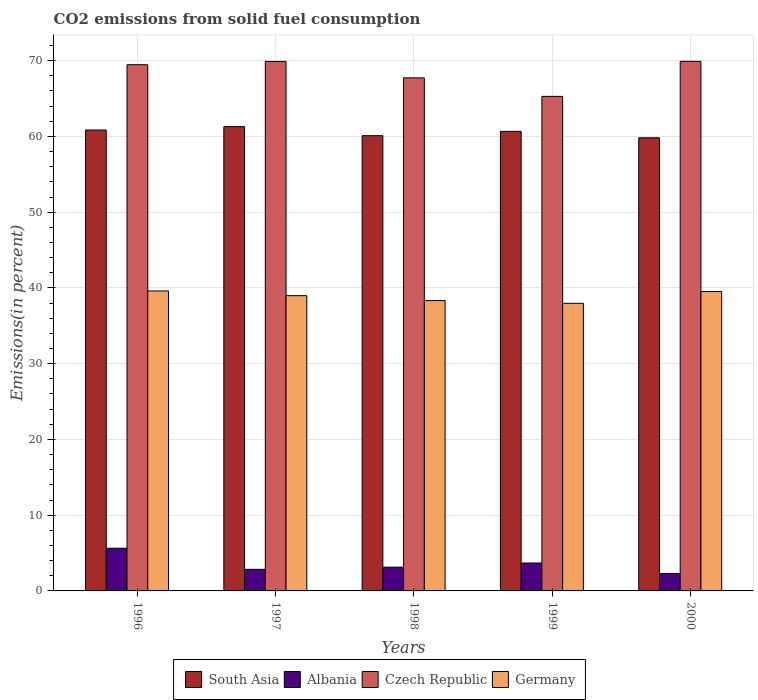How many groups of bars are there?
Offer a terse response. 5. Are the number of bars per tick equal to the number of legend labels?
Your response must be concise. Yes. Are the number of bars on each tick of the X-axis equal?
Offer a terse response. Yes. How many bars are there on the 5th tick from the left?
Provide a succinct answer. 4. How many bars are there on the 3rd tick from the right?
Keep it short and to the point. 4. What is the total CO2 emitted in South Asia in 1999?
Keep it short and to the point. 60.67. Across all years, what is the maximum total CO2 emitted in South Asia?
Your answer should be compact. 61.29. Across all years, what is the minimum total CO2 emitted in Albania?
Your response must be concise. 2.31. In which year was the total CO2 emitted in Czech Republic minimum?
Your response must be concise. 1999. What is the total total CO2 emitted in South Asia in the graph?
Keep it short and to the point. 302.74. What is the difference between the total CO2 emitted in South Asia in 1996 and that in 1999?
Your response must be concise. 0.18. What is the difference between the total CO2 emitted in South Asia in 2000 and the total CO2 emitted in Czech Republic in 1996?
Your answer should be compact. -9.65. What is the average total CO2 emitted in South Asia per year?
Your answer should be compact. 60.55. In the year 1997, what is the difference between the total CO2 emitted in Albania and total CO2 emitted in Germany?
Ensure brevity in your answer.  -36.13. In how many years, is the total CO2 emitted in Germany greater than 6 %?
Make the answer very short. 5. What is the ratio of the total CO2 emitted in Czech Republic in 1997 to that in 2000?
Offer a very short reply. 1. Is the total CO2 emitted in South Asia in 1996 less than that in 1999?
Offer a very short reply. No. What is the difference between the highest and the second highest total CO2 emitted in Albania?
Give a very brief answer. 1.95. What is the difference between the highest and the lowest total CO2 emitted in Czech Republic?
Make the answer very short. 4.62. In how many years, is the total CO2 emitted in Albania greater than the average total CO2 emitted in Albania taken over all years?
Give a very brief answer. 2. What does the 2nd bar from the left in 2000 represents?
Provide a succinct answer. Albania. What does the 4th bar from the right in 1999 represents?
Ensure brevity in your answer.  South Asia. Are all the bars in the graph horizontal?
Your response must be concise. No. What is the difference between two consecutive major ticks on the Y-axis?
Ensure brevity in your answer.  10. Does the graph contain any zero values?
Offer a very short reply. No. Where does the legend appear in the graph?
Offer a terse response. Bottom center. What is the title of the graph?
Ensure brevity in your answer.  CO2 emissions from solid fuel consumption. Does "Uganda" appear as one of the legend labels in the graph?
Provide a short and direct response. No. What is the label or title of the Y-axis?
Keep it short and to the point. Emissions(in percent). What is the Emissions(in percent) of South Asia in 1996?
Keep it short and to the point. 60.85. What is the Emissions(in percent) of Albania in 1996?
Your answer should be very brief. 5.64. What is the Emissions(in percent) of Czech Republic in 1996?
Make the answer very short. 69.47. What is the Emissions(in percent) in Germany in 1996?
Provide a short and direct response. 39.6. What is the Emissions(in percent) in South Asia in 1997?
Your answer should be compact. 61.29. What is the Emissions(in percent) of Albania in 1997?
Give a very brief answer. 2.85. What is the Emissions(in percent) in Czech Republic in 1997?
Give a very brief answer. 69.9. What is the Emissions(in percent) of Germany in 1997?
Your answer should be compact. 38.98. What is the Emissions(in percent) in South Asia in 1998?
Give a very brief answer. 60.1. What is the Emissions(in percent) in Albania in 1998?
Your answer should be very brief. 3.14. What is the Emissions(in percent) of Czech Republic in 1998?
Your answer should be very brief. 67.73. What is the Emissions(in percent) in Germany in 1998?
Ensure brevity in your answer.  38.33. What is the Emissions(in percent) in South Asia in 1999?
Your answer should be compact. 60.67. What is the Emissions(in percent) of Albania in 1999?
Your answer should be compact. 3.69. What is the Emissions(in percent) in Czech Republic in 1999?
Your answer should be compact. 65.29. What is the Emissions(in percent) in Germany in 1999?
Keep it short and to the point. 37.97. What is the Emissions(in percent) in South Asia in 2000?
Your response must be concise. 59.82. What is the Emissions(in percent) of Albania in 2000?
Provide a short and direct response. 2.31. What is the Emissions(in percent) in Czech Republic in 2000?
Offer a very short reply. 69.91. What is the Emissions(in percent) of Germany in 2000?
Your response must be concise. 39.53. Across all years, what is the maximum Emissions(in percent) of South Asia?
Ensure brevity in your answer.  61.29. Across all years, what is the maximum Emissions(in percent) of Albania?
Your response must be concise. 5.64. Across all years, what is the maximum Emissions(in percent) in Czech Republic?
Offer a very short reply. 69.91. Across all years, what is the maximum Emissions(in percent) in Germany?
Keep it short and to the point. 39.6. Across all years, what is the minimum Emissions(in percent) of South Asia?
Give a very brief answer. 59.82. Across all years, what is the minimum Emissions(in percent) in Albania?
Offer a very short reply. 2.31. Across all years, what is the minimum Emissions(in percent) in Czech Republic?
Your answer should be compact. 65.29. Across all years, what is the minimum Emissions(in percent) in Germany?
Make the answer very short. 37.97. What is the total Emissions(in percent) of South Asia in the graph?
Give a very brief answer. 302.74. What is the total Emissions(in percent) in Albania in the graph?
Your answer should be compact. 17.62. What is the total Emissions(in percent) of Czech Republic in the graph?
Make the answer very short. 342.31. What is the total Emissions(in percent) of Germany in the graph?
Your answer should be very brief. 194.41. What is the difference between the Emissions(in percent) of South Asia in 1996 and that in 1997?
Offer a very short reply. -0.45. What is the difference between the Emissions(in percent) of Albania in 1996 and that in 1997?
Ensure brevity in your answer.  2.79. What is the difference between the Emissions(in percent) of Czech Republic in 1996 and that in 1997?
Offer a terse response. -0.43. What is the difference between the Emissions(in percent) of Germany in 1996 and that in 1997?
Offer a very short reply. 0.62. What is the difference between the Emissions(in percent) of South Asia in 1996 and that in 1998?
Offer a very short reply. 0.75. What is the difference between the Emissions(in percent) of Albania in 1996 and that in 1998?
Provide a succinct answer. 2.5. What is the difference between the Emissions(in percent) in Czech Republic in 1996 and that in 1998?
Give a very brief answer. 1.74. What is the difference between the Emissions(in percent) in Germany in 1996 and that in 1998?
Provide a short and direct response. 1.26. What is the difference between the Emissions(in percent) in South Asia in 1996 and that in 1999?
Your answer should be very brief. 0.18. What is the difference between the Emissions(in percent) of Albania in 1996 and that in 1999?
Offer a very short reply. 1.95. What is the difference between the Emissions(in percent) in Czech Republic in 1996 and that in 1999?
Your response must be concise. 4.18. What is the difference between the Emissions(in percent) in Germany in 1996 and that in 1999?
Keep it short and to the point. 1.63. What is the difference between the Emissions(in percent) in South Asia in 1996 and that in 2000?
Provide a succinct answer. 1.03. What is the difference between the Emissions(in percent) of Albania in 1996 and that in 2000?
Keep it short and to the point. 3.33. What is the difference between the Emissions(in percent) in Czech Republic in 1996 and that in 2000?
Your answer should be compact. -0.44. What is the difference between the Emissions(in percent) of Germany in 1996 and that in 2000?
Provide a succinct answer. 0.07. What is the difference between the Emissions(in percent) of South Asia in 1997 and that in 1998?
Provide a short and direct response. 1.19. What is the difference between the Emissions(in percent) of Albania in 1997 and that in 1998?
Make the answer very short. -0.29. What is the difference between the Emissions(in percent) in Czech Republic in 1997 and that in 1998?
Ensure brevity in your answer.  2.17. What is the difference between the Emissions(in percent) in Germany in 1997 and that in 1998?
Offer a terse response. 0.64. What is the difference between the Emissions(in percent) in South Asia in 1997 and that in 1999?
Make the answer very short. 0.62. What is the difference between the Emissions(in percent) in Albania in 1997 and that in 1999?
Offer a very short reply. -0.84. What is the difference between the Emissions(in percent) in Czech Republic in 1997 and that in 1999?
Offer a very short reply. 4.61. What is the difference between the Emissions(in percent) of Germany in 1997 and that in 1999?
Offer a terse response. 1.01. What is the difference between the Emissions(in percent) of South Asia in 1997 and that in 2000?
Give a very brief answer. 1.47. What is the difference between the Emissions(in percent) in Albania in 1997 and that in 2000?
Keep it short and to the point. 0.54. What is the difference between the Emissions(in percent) in Czech Republic in 1997 and that in 2000?
Offer a very short reply. -0.01. What is the difference between the Emissions(in percent) of Germany in 1997 and that in 2000?
Provide a short and direct response. -0.55. What is the difference between the Emissions(in percent) of South Asia in 1998 and that in 1999?
Ensure brevity in your answer.  -0.57. What is the difference between the Emissions(in percent) of Albania in 1998 and that in 1999?
Offer a very short reply. -0.55. What is the difference between the Emissions(in percent) of Czech Republic in 1998 and that in 1999?
Make the answer very short. 2.45. What is the difference between the Emissions(in percent) in Germany in 1998 and that in 1999?
Ensure brevity in your answer.  0.37. What is the difference between the Emissions(in percent) in South Asia in 1998 and that in 2000?
Give a very brief answer. 0.28. What is the difference between the Emissions(in percent) of Albania in 1998 and that in 2000?
Ensure brevity in your answer.  0.83. What is the difference between the Emissions(in percent) in Czech Republic in 1998 and that in 2000?
Offer a very short reply. -2.18. What is the difference between the Emissions(in percent) of Germany in 1998 and that in 2000?
Provide a short and direct response. -1.19. What is the difference between the Emissions(in percent) of South Asia in 1999 and that in 2000?
Your answer should be compact. 0.85. What is the difference between the Emissions(in percent) in Albania in 1999 and that in 2000?
Keep it short and to the point. 1.38. What is the difference between the Emissions(in percent) in Czech Republic in 1999 and that in 2000?
Ensure brevity in your answer.  -4.62. What is the difference between the Emissions(in percent) in Germany in 1999 and that in 2000?
Your response must be concise. -1.56. What is the difference between the Emissions(in percent) in South Asia in 1996 and the Emissions(in percent) in Albania in 1997?
Provide a short and direct response. 58. What is the difference between the Emissions(in percent) of South Asia in 1996 and the Emissions(in percent) of Czech Republic in 1997?
Offer a terse response. -9.05. What is the difference between the Emissions(in percent) of South Asia in 1996 and the Emissions(in percent) of Germany in 1997?
Provide a short and direct response. 21.87. What is the difference between the Emissions(in percent) in Albania in 1996 and the Emissions(in percent) in Czech Republic in 1997?
Provide a short and direct response. -64.27. What is the difference between the Emissions(in percent) of Albania in 1996 and the Emissions(in percent) of Germany in 1997?
Your answer should be very brief. -33.34. What is the difference between the Emissions(in percent) in Czech Republic in 1996 and the Emissions(in percent) in Germany in 1997?
Give a very brief answer. 30.49. What is the difference between the Emissions(in percent) in South Asia in 1996 and the Emissions(in percent) in Albania in 1998?
Your answer should be compact. 57.71. What is the difference between the Emissions(in percent) in South Asia in 1996 and the Emissions(in percent) in Czech Republic in 1998?
Provide a short and direct response. -6.89. What is the difference between the Emissions(in percent) in South Asia in 1996 and the Emissions(in percent) in Germany in 1998?
Provide a short and direct response. 22.51. What is the difference between the Emissions(in percent) of Albania in 1996 and the Emissions(in percent) of Czech Republic in 1998?
Ensure brevity in your answer.  -62.1. What is the difference between the Emissions(in percent) of Albania in 1996 and the Emissions(in percent) of Germany in 1998?
Offer a very short reply. -32.7. What is the difference between the Emissions(in percent) of Czech Republic in 1996 and the Emissions(in percent) of Germany in 1998?
Ensure brevity in your answer.  31.14. What is the difference between the Emissions(in percent) of South Asia in 1996 and the Emissions(in percent) of Albania in 1999?
Your answer should be compact. 57.16. What is the difference between the Emissions(in percent) of South Asia in 1996 and the Emissions(in percent) of Czech Republic in 1999?
Keep it short and to the point. -4.44. What is the difference between the Emissions(in percent) of South Asia in 1996 and the Emissions(in percent) of Germany in 1999?
Offer a very short reply. 22.88. What is the difference between the Emissions(in percent) of Albania in 1996 and the Emissions(in percent) of Czech Republic in 1999?
Offer a terse response. -59.65. What is the difference between the Emissions(in percent) of Albania in 1996 and the Emissions(in percent) of Germany in 1999?
Your response must be concise. -32.33. What is the difference between the Emissions(in percent) in Czech Republic in 1996 and the Emissions(in percent) in Germany in 1999?
Your response must be concise. 31.5. What is the difference between the Emissions(in percent) in South Asia in 1996 and the Emissions(in percent) in Albania in 2000?
Ensure brevity in your answer.  58.54. What is the difference between the Emissions(in percent) of South Asia in 1996 and the Emissions(in percent) of Czech Republic in 2000?
Ensure brevity in your answer.  -9.06. What is the difference between the Emissions(in percent) of South Asia in 1996 and the Emissions(in percent) of Germany in 2000?
Your answer should be very brief. 21.32. What is the difference between the Emissions(in percent) of Albania in 1996 and the Emissions(in percent) of Czech Republic in 2000?
Your response must be concise. -64.28. What is the difference between the Emissions(in percent) of Albania in 1996 and the Emissions(in percent) of Germany in 2000?
Keep it short and to the point. -33.89. What is the difference between the Emissions(in percent) in Czech Republic in 1996 and the Emissions(in percent) in Germany in 2000?
Provide a short and direct response. 29.94. What is the difference between the Emissions(in percent) in South Asia in 1997 and the Emissions(in percent) in Albania in 1998?
Provide a succinct answer. 58.16. What is the difference between the Emissions(in percent) of South Asia in 1997 and the Emissions(in percent) of Czech Republic in 1998?
Give a very brief answer. -6.44. What is the difference between the Emissions(in percent) in South Asia in 1997 and the Emissions(in percent) in Germany in 1998?
Offer a very short reply. 22.96. What is the difference between the Emissions(in percent) in Albania in 1997 and the Emissions(in percent) in Czech Republic in 1998?
Offer a very short reply. -64.88. What is the difference between the Emissions(in percent) in Albania in 1997 and the Emissions(in percent) in Germany in 1998?
Provide a short and direct response. -35.48. What is the difference between the Emissions(in percent) of Czech Republic in 1997 and the Emissions(in percent) of Germany in 1998?
Provide a succinct answer. 31.57. What is the difference between the Emissions(in percent) in South Asia in 1997 and the Emissions(in percent) in Albania in 1999?
Offer a terse response. 57.61. What is the difference between the Emissions(in percent) of South Asia in 1997 and the Emissions(in percent) of Czech Republic in 1999?
Your answer should be very brief. -3.99. What is the difference between the Emissions(in percent) of South Asia in 1997 and the Emissions(in percent) of Germany in 1999?
Keep it short and to the point. 23.33. What is the difference between the Emissions(in percent) of Albania in 1997 and the Emissions(in percent) of Czech Republic in 1999?
Provide a succinct answer. -62.44. What is the difference between the Emissions(in percent) in Albania in 1997 and the Emissions(in percent) in Germany in 1999?
Give a very brief answer. -35.12. What is the difference between the Emissions(in percent) of Czech Republic in 1997 and the Emissions(in percent) of Germany in 1999?
Make the answer very short. 31.93. What is the difference between the Emissions(in percent) in South Asia in 1997 and the Emissions(in percent) in Albania in 2000?
Provide a short and direct response. 58.99. What is the difference between the Emissions(in percent) of South Asia in 1997 and the Emissions(in percent) of Czech Republic in 2000?
Provide a short and direct response. -8.62. What is the difference between the Emissions(in percent) of South Asia in 1997 and the Emissions(in percent) of Germany in 2000?
Keep it short and to the point. 21.77. What is the difference between the Emissions(in percent) of Albania in 1997 and the Emissions(in percent) of Czech Republic in 2000?
Provide a short and direct response. -67.06. What is the difference between the Emissions(in percent) in Albania in 1997 and the Emissions(in percent) in Germany in 2000?
Provide a succinct answer. -36.68. What is the difference between the Emissions(in percent) in Czech Republic in 1997 and the Emissions(in percent) in Germany in 2000?
Your answer should be very brief. 30.38. What is the difference between the Emissions(in percent) in South Asia in 1998 and the Emissions(in percent) in Albania in 1999?
Keep it short and to the point. 56.41. What is the difference between the Emissions(in percent) of South Asia in 1998 and the Emissions(in percent) of Czech Republic in 1999?
Provide a short and direct response. -5.19. What is the difference between the Emissions(in percent) of South Asia in 1998 and the Emissions(in percent) of Germany in 1999?
Give a very brief answer. 22.13. What is the difference between the Emissions(in percent) of Albania in 1998 and the Emissions(in percent) of Czech Republic in 1999?
Give a very brief answer. -62.15. What is the difference between the Emissions(in percent) in Albania in 1998 and the Emissions(in percent) in Germany in 1999?
Make the answer very short. -34.83. What is the difference between the Emissions(in percent) in Czech Republic in 1998 and the Emissions(in percent) in Germany in 1999?
Your response must be concise. 29.77. What is the difference between the Emissions(in percent) in South Asia in 1998 and the Emissions(in percent) in Albania in 2000?
Offer a very short reply. 57.79. What is the difference between the Emissions(in percent) of South Asia in 1998 and the Emissions(in percent) of Czech Republic in 2000?
Provide a succinct answer. -9.81. What is the difference between the Emissions(in percent) of South Asia in 1998 and the Emissions(in percent) of Germany in 2000?
Give a very brief answer. 20.57. What is the difference between the Emissions(in percent) of Albania in 1998 and the Emissions(in percent) of Czech Republic in 2000?
Offer a very short reply. -66.78. What is the difference between the Emissions(in percent) of Albania in 1998 and the Emissions(in percent) of Germany in 2000?
Keep it short and to the point. -36.39. What is the difference between the Emissions(in percent) of Czech Republic in 1998 and the Emissions(in percent) of Germany in 2000?
Ensure brevity in your answer.  28.21. What is the difference between the Emissions(in percent) in South Asia in 1999 and the Emissions(in percent) in Albania in 2000?
Make the answer very short. 58.37. What is the difference between the Emissions(in percent) of South Asia in 1999 and the Emissions(in percent) of Czech Republic in 2000?
Your answer should be compact. -9.24. What is the difference between the Emissions(in percent) in South Asia in 1999 and the Emissions(in percent) in Germany in 2000?
Ensure brevity in your answer.  21.14. What is the difference between the Emissions(in percent) in Albania in 1999 and the Emissions(in percent) in Czech Republic in 2000?
Provide a succinct answer. -66.23. What is the difference between the Emissions(in percent) of Albania in 1999 and the Emissions(in percent) of Germany in 2000?
Make the answer very short. -35.84. What is the difference between the Emissions(in percent) in Czech Republic in 1999 and the Emissions(in percent) in Germany in 2000?
Provide a succinct answer. 25.76. What is the average Emissions(in percent) of South Asia per year?
Ensure brevity in your answer.  60.55. What is the average Emissions(in percent) in Albania per year?
Your answer should be very brief. 3.52. What is the average Emissions(in percent) of Czech Republic per year?
Your response must be concise. 68.46. What is the average Emissions(in percent) of Germany per year?
Your response must be concise. 38.88. In the year 1996, what is the difference between the Emissions(in percent) in South Asia and Emissions(in percent) in Albania?
Your answer should be compact. 55.21. In the year 1996, what is the difference between the Emissions(in percent) in South Asia and Emissions(in percent) in Czech Republic?
Your answer should be very brief. -8.62. In the year 1996, what is the difference between the Emissions(in percent) in South Asia and Emissions(in percent) in Germany?
Make the answer very short. 21.25. In the year 1996, what is the difference between the Emissions(in percent) of Albania and Emissions(in percent) of Czech Republic?
Your answer should be very brief. -63.83. In the year 1996, what is the difference between the Emissions(in percent) in Albania and Emissions(in percent) in Germany?
Keep it short and to the point. -33.96. In the year 1996, what is the difference between the Emissions(in percent) in Czech Republic and Emissions(in percent) in Germany?
Provide a short and direct response. 29.87. In the year 1997, what is the difference between the Emissions(in percent) of South Asia and Emissions(in percent) of Albania?
Ensure brevity in your answer.  58.44. In the year 1997, what is the difference between the Emissions(in percent) in South Asia and Emissions(in percent) in Czech Republic?
Ensure brevity in your answer.  -8.61. In the year 1997, what is the difference between the Emissions(in percent) of South Asia and Emissions(in percent) of Germany?
Provide a succinct answer. 22.32. In the year 1997, what is the difference between the Emissions(in percent) of Albania and Emissions(in percent) of Czech Republic?
Your answer should be very brief. -67.05. In the year 1997, what is the difference between the Emissions(in percent) in Albania and Emissions(in percent) in Germany?
Offer a very short reply. -36.13. In the year 1997, what is the difference between the Emissions(in percent) in Czech Republic and Emissions(in percent) in Germany?
Offer a terse response. 30.92. In the year 1998, what is the difference between the Emissions(in percent) in South Asia and Emissions(in percent) in Albania?
Make the answer very short. 56.96. In the year 1998, what is the difference between the Emissions(in percent) in South Asia and Emissions(in percent) in Czech Republic?
Your answer should be compact. -7.63. In the year 1998, what is the difference between the Emissions(in percent) in South Asia and Emissions(in percent) in Germany?
Your response must be concise. 21.77. In the year 1998, what is the difference between the Emissions(in percent) in Albania and Emissions(in percent) in Czech Republic?
Provide a short and direct response. -64.6. In the year 1998, what is the difference between the Emissions(in percent) in Albania and Emissions(in percent) in Germany?
Your answer should be very brief. -35.2. In the year 1998, what is the difference between the Emissions(in percent) of Czech Republic and Emissions(in percent) of Germany?
Provide a succinct answer. 29.4. In the year 1999, what is the difference between the Emissions(in percent) in South Asia and Emissions(in percent) in Albania?
Offer a very short reply. 56.99. In the year 1999, what is the difference between the Emissions(in percent) of South Asia and Emissions(in percent) of Czech Republic?
Make the answer very short. -4.62. In the year 1999, what is the difference between the Emissions(in percent) in South Asia and Emissions(in percent) in Germany?
Offer a terse response. 22.7. In the year 1999, what is the difference between the Emissions(in percent) of Albania and Emissions(in percent) of Czech Republic?
Keep it short and to the point. -61.6. In the year 1999, what is the difference between the Emissions(in percent) of Albania and Emissions(in percent) of Germany?
Provide a succinct answer. -34.28. In the year 1999, what is the difference between the Emissions(in percent) of Czech Republic and Emissions(in percent) of Germany?
Give a very brief answer. 27.32. In the year 2000, what is the difference between the Emissions(in percent) in South Asia and Emissions(in percent) in Albania?
Ensure brevity in your answer.  57.51. In the year 2000, what is the difference between the Emissions(in percent) of South Asia and Emissions(in percent) of Czech Republic?
Your answer should be compact. -10.09. In the year 2000, what is the difference between the Emissions(in percent) in South Asia and Emissions(in percent) in Germany?
Your response must be concise. 20.29. In the year 2000, what is the difference between the Emissions(in percent) of Albania and Emissions(in percent) of Czech Republic?
Give a very brief answer. -67.61. In the year 2000, what is the difference between the Emissions(in percent) of Albania and Emissions(in percent) of Germany?
Your answer should be very brief. -37.22. In the year 2000, what is the difference between the Emissions(in percent) in Czech Republic and Emissions(in percent) in Germany?
Make the answer very short. 30.39. What is the ratio of the Emissions(in percent) in South Asia in 1996 to that in 1997?
Provide a succinct answer. 0.99. What is the ratio of the Emissions(in percent) of Albania in 1996 to that in 1997?
Provide a short and direct response. 1.98. What is the ratio of the Emissions(in percent) in Germany in 1996 to that in 1997?
Your response must be concise. 1.02. What is the ratio of the Emissions(in percent) of South Asia in 1996 to that in 1998?
Provide a short and direct response. 1.01. What is the ratio of the Emissions(in percent) in Albania in 1996 to that in 1998?
Provide a succinct answer. 1.8. What is the ratio of the Emissions(in percent) of Czech Republic in 1996 to that in 1998?
Your answer should be compact. 1.03. What is the ratio of the Emissions(in percent) in Germany in 1996 to that in 1998?
Your response must be concise. 1.03. What is the ratio of the Emissions(in percent) in Albania in 1996 to that in 1999?
Offer a terse response. 1.53. What is the ratio of the Emissions(in percent) in Czech Republic in 1996 to that in 1999?
Make the answer very short. 1.06. What is the ratio of the Emissions(in percent) of Germany in 1996 to that in 1999?
Provide a short and direct response. 1.04. What is the ratio of the Emissions(in percent) in South Asia in 1996 to that in 2000?
Ensure brevity in your answer.  1.02. What is the ratio of the Emissions(in percent) of Albania in 1996 to that in 2000?
Ensure brevity in your answer.  2.44. What is the ratio of the Emissions(in percent) of Czech Republic in 1996 to that in 2000?
Keep it short and to the point. 0.99. What is the ratio of the Emissions(in percent) of Germany in 1996 to that in 2000?
Make the answer very short. 1. What is the ratio of the Emissions(in percent) of South Asia in 1997 to that in 1998?
Provide a short and direct response. 1.02. What is the ratio of the Emissions(in percent) of Albania in 1997 to that in 1998?
Provide a succinct answer. 0.91. What is the ratio of the Emissions(in percent) in Czech Republic in 1997 to that in 1998?
Provide a short and direct response. 1.03. What is the ratio of the Emissions(in percent) of Germany in 1997 to that in 1998?
Provide a succinct answer. 1.02. What is the ratio of the Emissions(in percent) in South Asia in 1997 to that in 1999?
Ensure brevity in your answer.  1.01. What is the ratio of the Emissions(in percent) in Albania in 1997 to that in 1999?
Offer a terse response. 0.77. What is the ratio of the Emissions(in percent) of Czech Republic in 1997 to that in 1999?
Your response must be concise. 1.07. What is the ratio of the Emissions(in percent) of Germany in 1997 to that in 1999?
Give a very brief answer. 1.03. What is the ratio of the Emissions(in percent) of South Asia in 1997 to that in 2000?
Give a very brief answer. 1.02. What is the ratio of the Emissions(in percent) in Albania in 1997 to that in 2000?
Give a very brief answer. 1.24. What is the ratio of the Emissions(in percent) in Czech Republic in 1997 to that in 2000?
Offer a terse response. 1. What is the ratio of the Emissions(in percent) of Germany in 1997 to that in 2000?
Make the answer very short. 0.99. What is the ratio of the Emissions(in percent) in South Asia in 1998 to that in 1999?
Ensure brevity in your answer.  0.99. What is the ratio of the Emissions(in percent) in Albania in 1998 to that in 1999?
Provide a succinct answer. 0.85. What is the ratio of the Emissions(in percent) in Czech Republic in 1998 to that in 1999?
Provide a short and direct response. 1.04. What is the ratio of the Emissions(in percent) in Germany in 1998 to that in 1999?
Offer a terse response. 1.01. What is the ratio of the Emissions(in percent) of Albania in 1998 to that in 2000?
Your answer should be very brief. 1.36. What is the ratio of the Emissions(in percent) in Czech Republic in 1998 to that in 2000?
Your answer should be compact. 0.97. What is the ratio of the Emissions(in percent) in Germany in 1998 to that in 2000?
Your response must be concise. 0.97. What is the ratio of the Emissions(in percent) in South Asia in 1999 to that in 2000?
Offer a terse response. 1.01. What is the ratio of the Emissions(in percent) of Albania in 1999 to that in 2000?
Offer a very short reply. 1.6. What is the ratio of the Emissions(in percent) in Czech Republic in 1999 to that in 2000?
Your response must be concise. 0.93. What is the ratio of the Emissions(in percent) in Germany in 1999 to that in 2000?
Keep it short and to the point. 0.96. What is the difference between the highest and the second highest Emissions(in percent) of South Asia?
Offer a very short reply. 0.45. What is the difference between the highest and the second highest Emissions(in percent) of Albania?
Provide a succinct answer. 1.95. What is the difference between the highest and the second highest Emissions(in percent) in Czech Republic?
Provide a short and direct response. 0.01. What is the difference between the highest and the second highest Emissions(in percent) of Germany?
Ensure brevity in your answer.  0.07. What is the difference between the highest and the lowest Emissions(in percent) in South Asia?
Ensure brevity in your answer.  1.47. What is the difference between the highest and the lowest Emissions(in percent) of Albania?
Offer a terse response. 3.33. What is the difference between the highest and the lowest Emissions(in percent) of Czech Republic?
Ensure brevity in your answer.  4.62. What is the difference between the highest and the lowest Emissions(in percent) of Germany?
Your answer should be very brief. 1.63. 